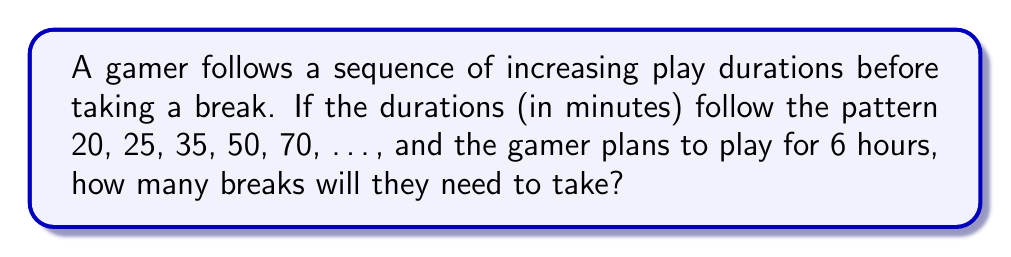Can you answer this question? Let's approach this step-by-step:

1) First, we need to identify the pattern in the sequence:
   20, 25, 35, 50, 70, ...
   
   The differences between consecutive terms are:
   5, 10, 15, 20, ...
   
   We can see that the differences form an arithmetic sequence with a common difference of 5.

2) We can express the nth term of this sequence as:
   $a_n = 20 + \frac{n(n-1)}{2} \cdot 5$

3) Now, we need to find how many terms of this sequence we can sum before exceeding 360 minutes (6 hours).

4) Let's calculate the cumulative sum:
   $S_n = \sum_{i=1}^n a_i = \sum_{i=1}^n (20 + \frac{i(i-1)}{2} \cdot 5)$

5) Simplifying:
   $S_n = 20n + 5 \sum_{i=1}^n \frac{i(i-1)}{2}$

6) Using the formula for the sum of squares and the sum of natural numbers:
   $S_n = 20n + 5 (\frac{n(n-1)(2n-1)}{12})$

7) We need to find the largest n for which $S_n \leq 360$

8) By trial and error or using a calculator:
   For n = 5: $S_5 = 200$ (less than 360)
   For n = 6: $S_6 = 325$ (less than 360)
   For n = 7: $S_7 = 475$ (greater than 360)

9) Therefore, the gamer can complete 6 play sessions before exceeding 6 hours.

10) The number of breaks needed is one less than the number of sessions, as breaks are taken between sessions.
Answer: 5 breaks 